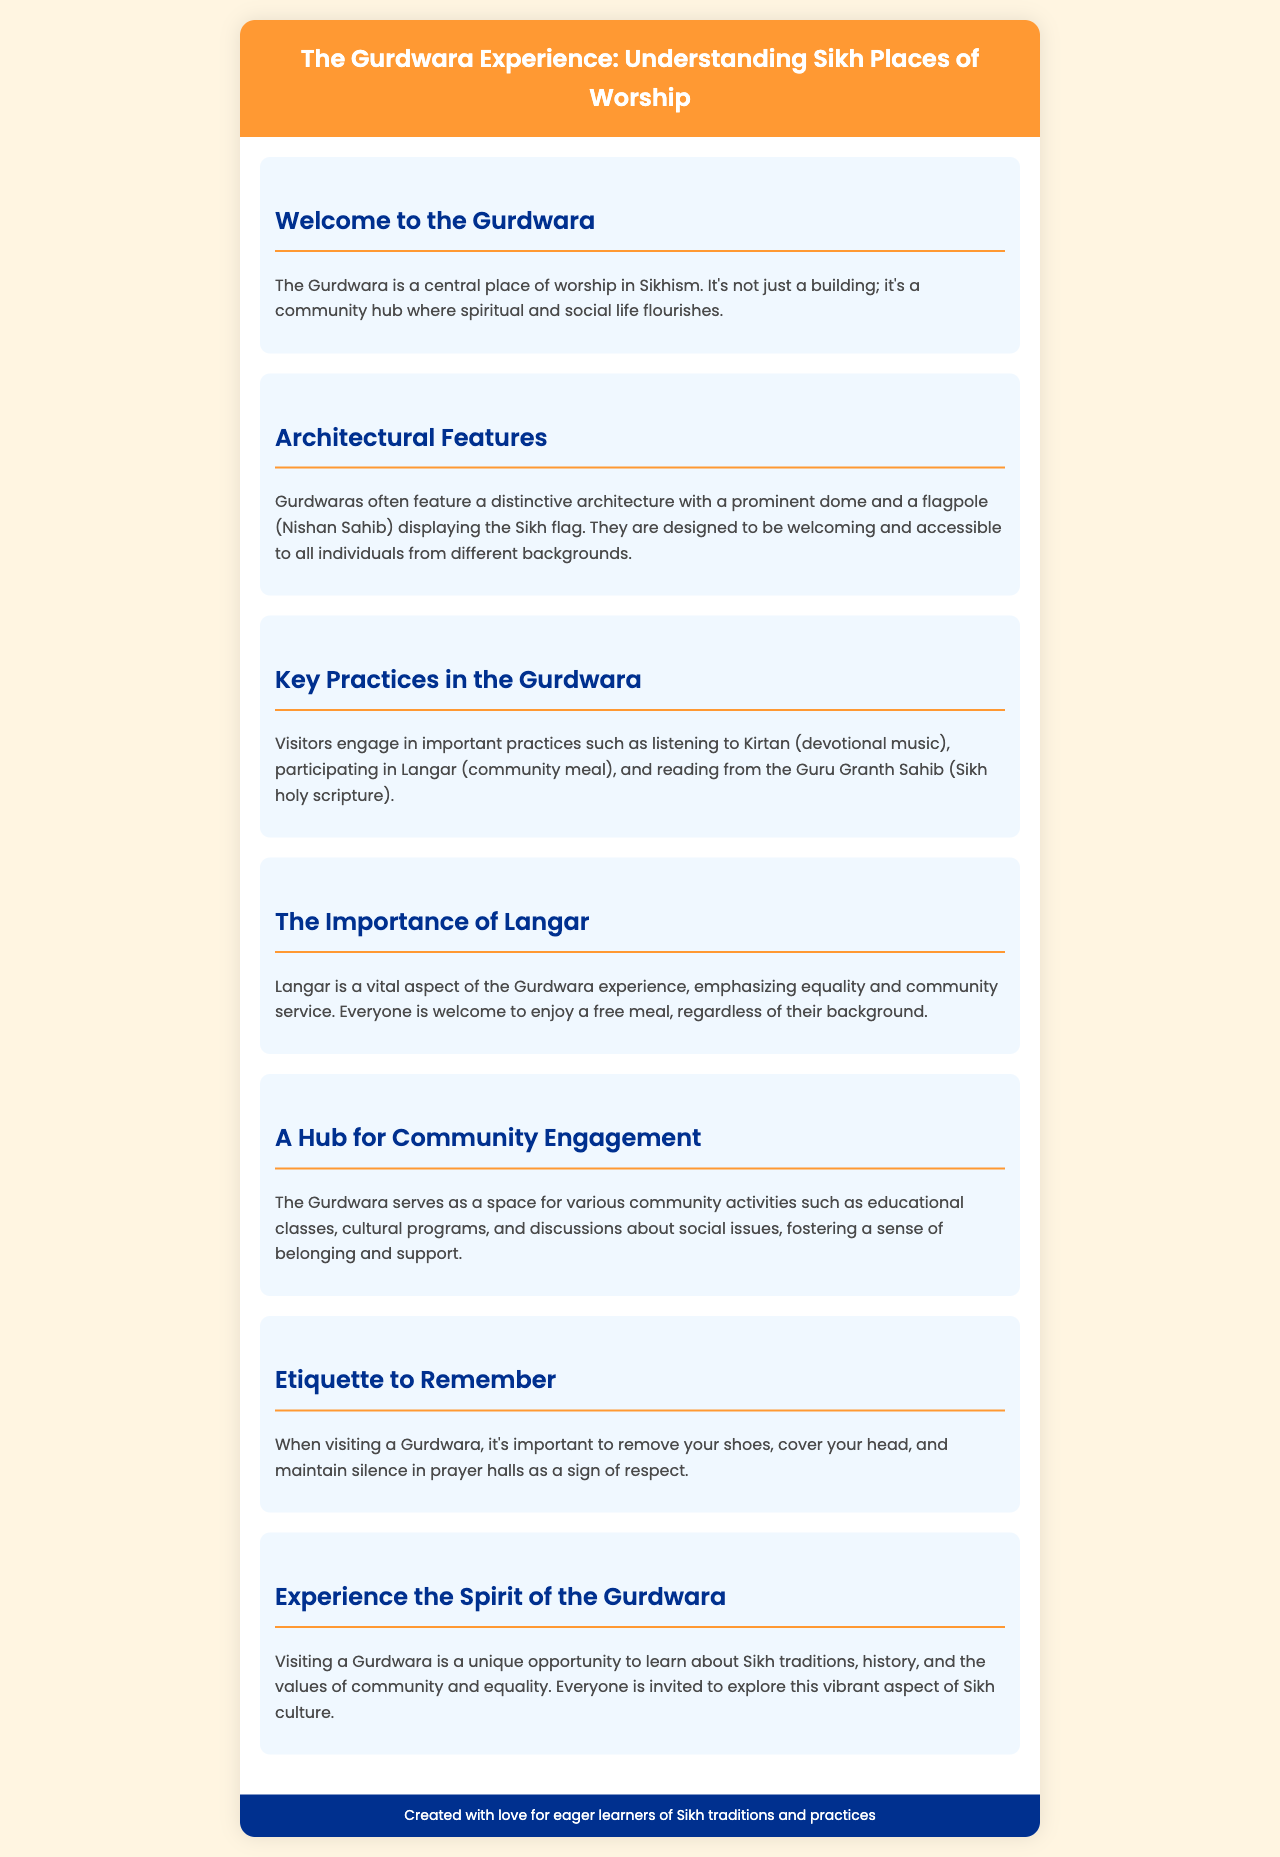What is the central place of worship in Sikhism? The Gurdwara is described as the central place of worship in Sikhism, emphasizing its significance.
Answer: The Gurdwara What is a prominent architectural feature of Gurdwaras? The document mentions that Gurdwaras often feature a distinct architecture with a prominent dome and a flagpole.
Answer: Dome and Nishan Sahib What is Langar? The text explains that Langar refers to the community meal served at the Gurdwara, which is a vital aspect of the experience.
Answer: Community meal What should visitors remember regarding etiquette? The section on etiquette outlines important rules visitors should follow when visiting a Gurdwara.
Answer: Remove shoes, cover head, maintain silence How does the Gurdwara foster community engagement? The document states that the Gurdwara serves as a space for community activities including educational classes and cultural programs.
Answer: Community activities What is emphasized through the practice of Langar? The text highlights that Langar emphasizes equality and community service during the dining experience.
Answer: Equality and community service 